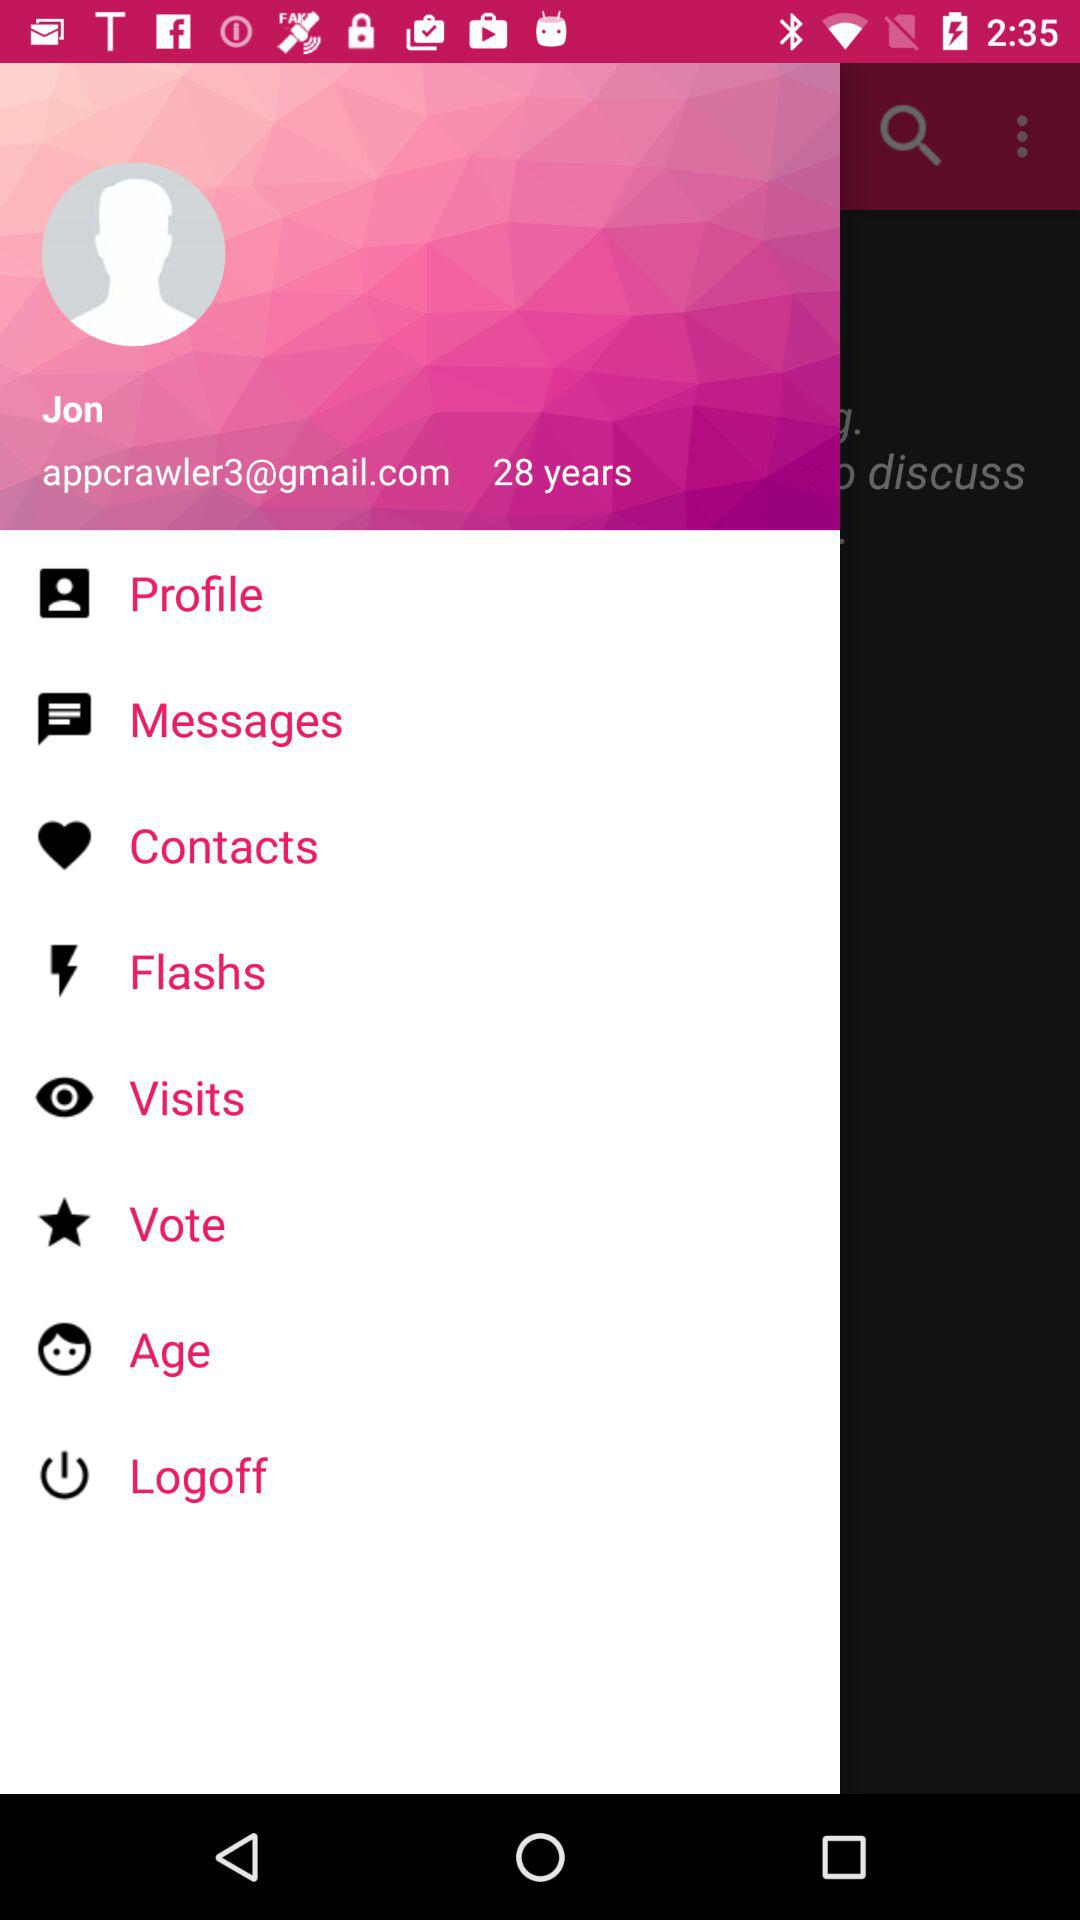What is the age of the user? The age of the user is 28 years old. 